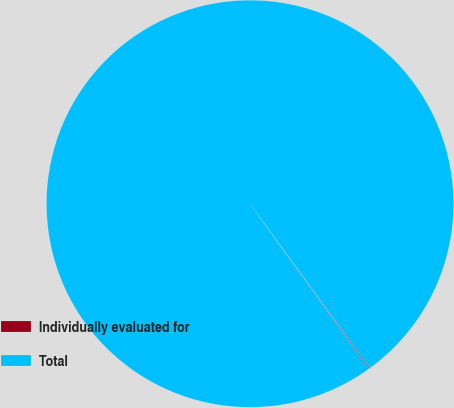Convert chart to OTSL. <chart><loc_0><loc_0><loc_500><loc_500><pie_chart><fcel>Individually evaluated for<fcel>Total<nl><fcel>0.09%<fcel>99.91%<nl></chart> 